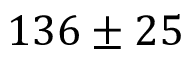Convert formula to latex. <formula><loc_0><loc_0><loc_500><loc_500>1 3 6 \pm 2 5</formula> 